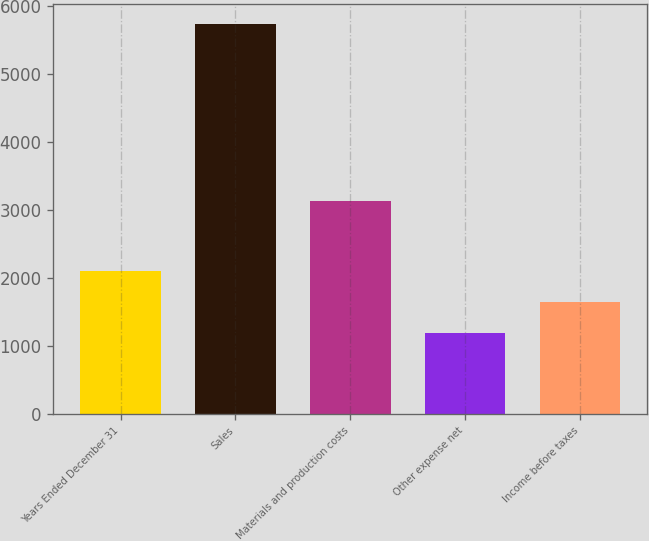Convert chart. <chart><loc_0><loc_0><loc_500><loc_500><bar_chart><fcel>Years Ended December 31<fcel>Sales<fcel>Materials and production costs<fcel>Other expense net<fcel>Income before taxes<nl><fcel>2104.08<fcel>5743.6<fcel>3136.6<fcel>1194.2<fcel>1649.14<nl></chart> 